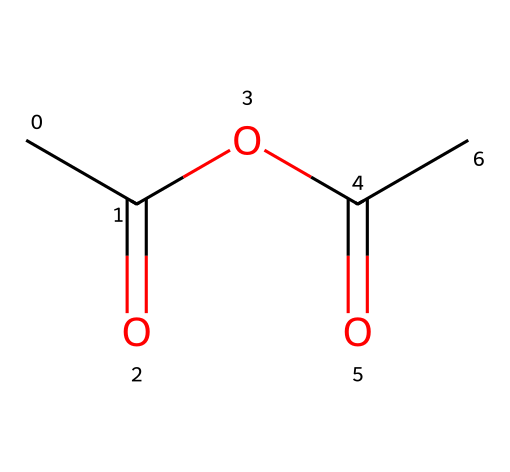What is the molecular formula of this compound? To determine the molecular formula, we need to count all the carbon (C), hydrogen (H), and oxygen (O) atoms in the chemical structure represented by the SMILES. From the structure, there are 4 carbons, 6 hydrogens, and 2 oxygens. Therefore, the molecular formula is C4H6O2.
Answer: C4H6O2 How many ester functional groups are present in this molecule? An ester functional group is characterized by the presence of a carbon atom double-bonded to an oxygen and also single-bonded to another oxygen (COO). In the provided structure, there are two distinct ester functional groups, confirming that there are two in total.
Answer: 2 How many double bonds are present in the chemical structure? In the SMILES representation, we can identify double bonds by looking for '=' signs. There are two carbonyl groups (C=O) in the molecule, which means there are 2 double bonds present in the structure.
Answer: 2 What type of chemical is acetic anhydride categorized as? Acetic anhydride is categorized as an acid anhydride, which consists of two acyl groups joined by an oxygen atom. Its structure contains elements characteristic of an acid anhydride, confirming this classification.
Answer: acid anhydride What is the state of acetic anhydride at room temperature? Acetic anhydride is a liquid at room temperature, which can be inferred based on its typical physical properties and common uses in various chemical processes, including food preservation.
Answer: liquid How does acetic anhydride react with water? When acetic anhydride reacts with water, it hydrolyzes to form acetic acid, which is the hallmark reaction of acid anhydrides. This is due to the structure facilitating the cleavage of the anhydride bond upon exposure to water.
Answer: forms acetic acid 